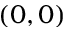Convert formula to latex. <formula><loc_0><loc_0><loc_500><loc_500>( 0 , 0 )</formula> 